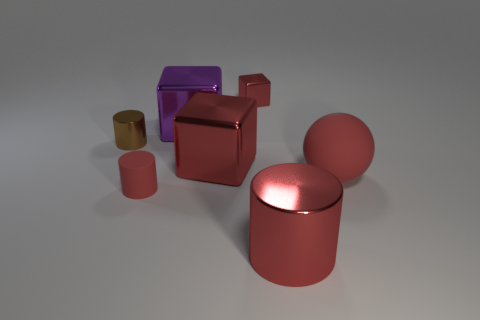Subtract all tiny red cubes. How many cubes are left? 2 Add 3 yellow cylinders. How many objects exist? 10 Subtract all purple cubes. How many cubes are left? 2 Subtract 2 cubes. How many cubes are left? 1 Subtract all brown cubes. How many brown cylinders are left? 1 Subtract all balls. How many objects are left? 6 Subtract all yellow cylinders. Subtract all cyan cubes. How many cylinders are left? 3 Subtract all large red shiny blocks. Subtract all large spheres. How many objects are left? 5 Add 4 matte things. How many matte things are left? 6 Add 6 big purple shiny blocks. How many big purple shiny blocks exist? 7 